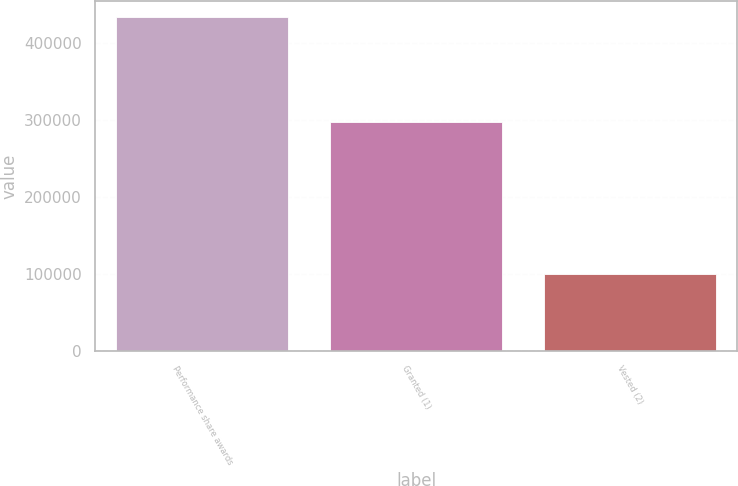<chart> <loc_0><loc_0><loc_500><loc_500><bar_chart><fcel>Performance share awards<fcel>Granted (1)<fcel>Vested (2)<nl><fcel>433230<fcel>297450<fcel>100170<nl></chart> 